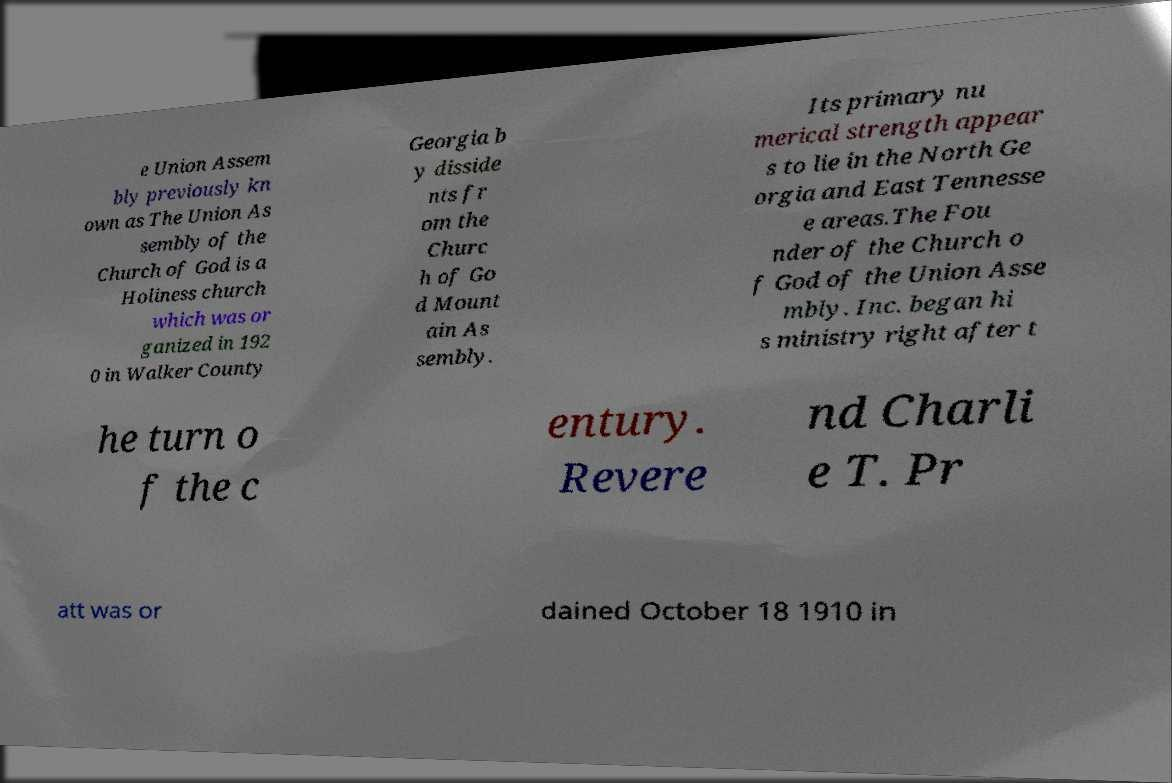What messages or text are displayed in this image? I need them in a readable, typed format. e Union Assem bly previously kn own as The Union As sembly of the Church of God is a Holiness church which was or ganized in 192 0 in Walker County Georgia b y disside nts fr om the Churc h of Go d Mount ain As sembly. Its primary nu merical strength appear s to lie in the North Ge orgia and East Tennesse e areas.The Fou nder of the Church o f God of the Union Asse mbly. Inc. began hi s ministry right after t he turn o f the c entury. Revere nd Charli e T. Pr att was or dained October 18 1910 in 